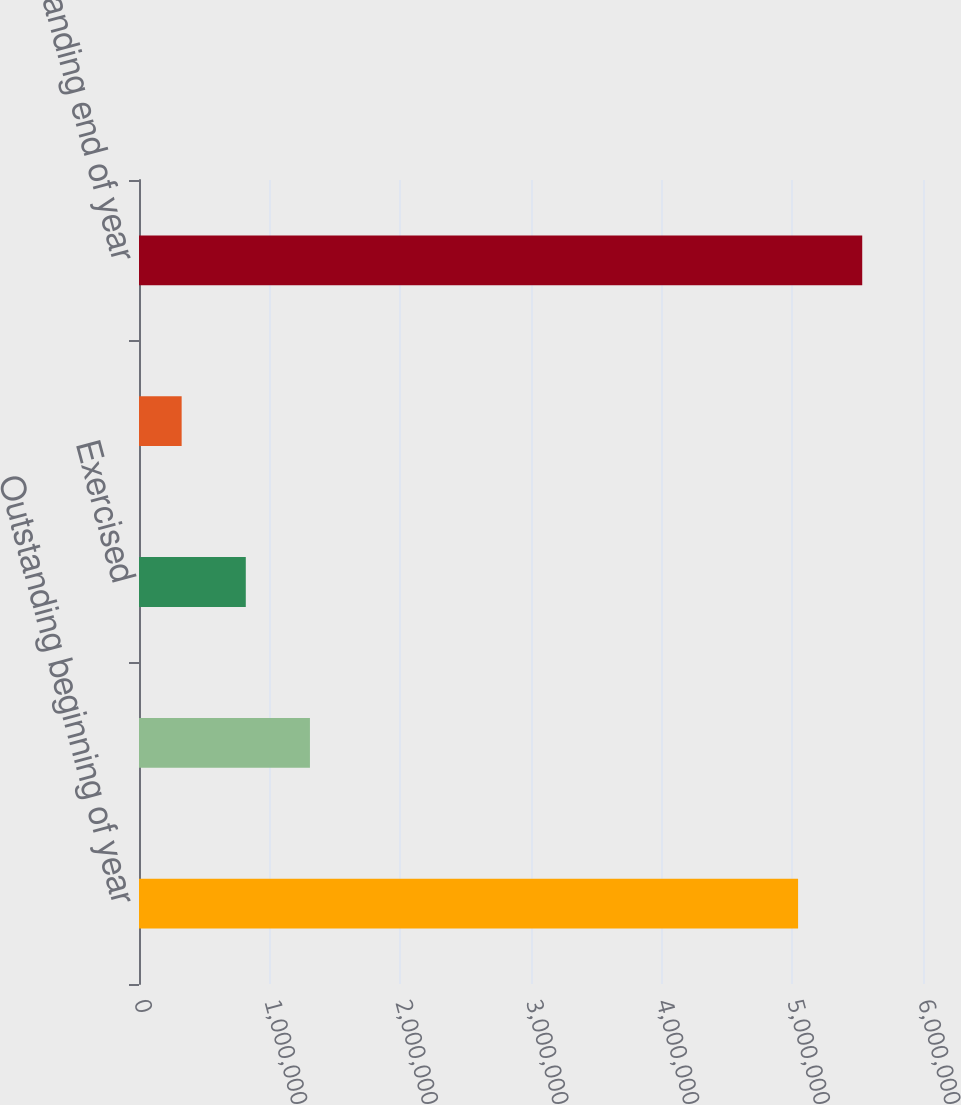Convert chart. <chart><loc_0><loc_0><loc_500><loc_500><bar_chart><fcel>Outstanding beginning of year<fcel>Granted<fcel>Exercised<fcel>Forfeited<fcel>Outstanding end of year<nl><fcel>5.04396e+06<fcel>1.30818e+06<fcel>817273<fcel>326363<fcel>5.53488e+06<nl></chart> 